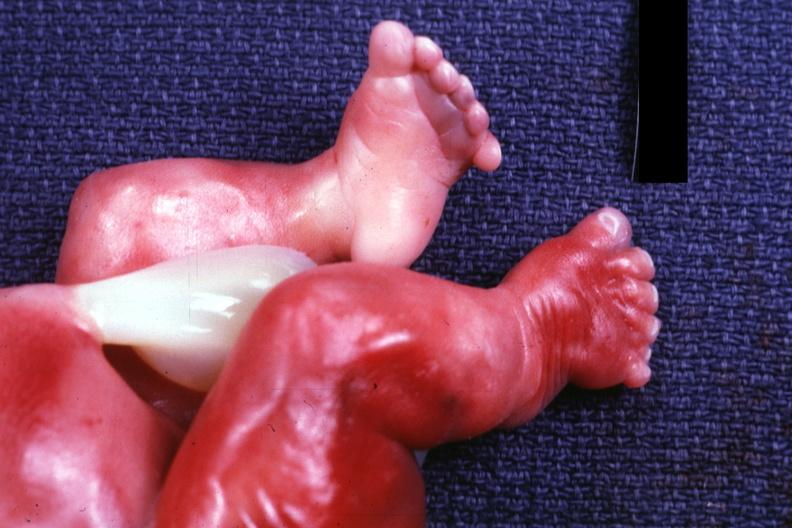how are newborn with renal polycystic disease legs too?
Answer the question using a single word or phrase. Short 